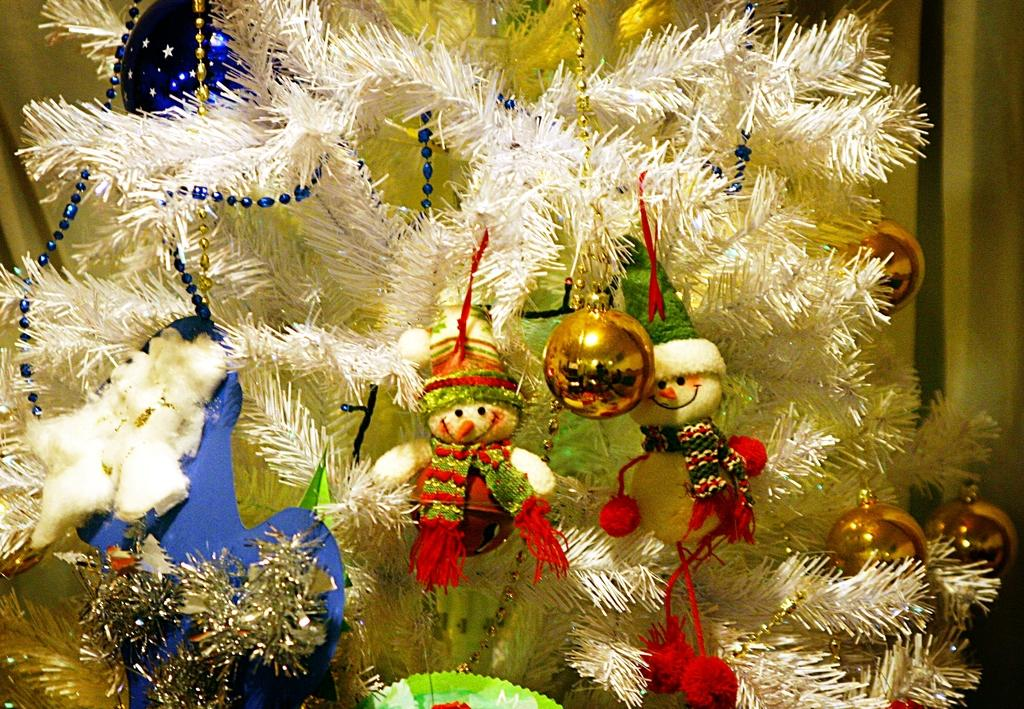What is one of the main objects in the picture? There is a tree in the picture. What else can be seen in the picture besides the tree? There are toys and fancy balls present in the picture. What is attached to the tree in the picture? Color ribbons are hanging from the tree. What can be seen in the background of the picture? There appears to be a curtain in the background. Can you see a tiger playing with the toys on the seashore in the image? There is no tiger or seashore present in the image. 